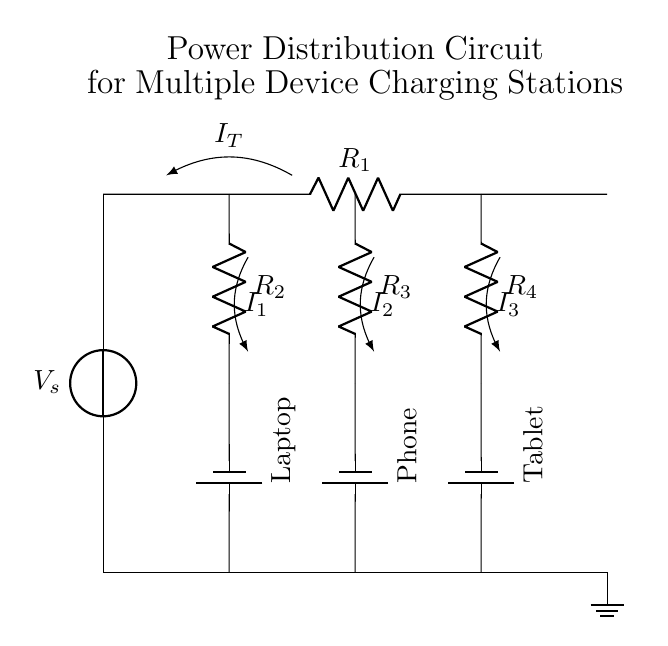What is the voltage source in this circuit? The voltage source is labeled as V_s, indicating the supply voltage for the circuit.
Answer: V_s What are the resistors in this circuit? The circuit contains four resistors labeled R_1, R_2, R_3, and R_4, each connected in different branches for current division.
Answer: R_1, R_2, R_3, R_4 How many charging stations are present in this circuit? There are three charging stations labeled for a Laptop, a Phone, and a Tablet, indicating the specific devices being powered.
Answer: Three What is the total current entering the circuit? The total current entering the circuit is labeled as I_T, which is the combined current flowing from the voltage source before it splits into different branches.
Answer: I_T What is the relationship between branch resistance and current? According to Ohm's Law, the current in each branch is inversely proportional to the branch's resistance; lower resistance allows more current to flow.
Answer: Inversely proportional Which device would receive the most current? The device connected to the branch with the smallest resistance will receive the most current, which can be determined by comparing the resistor values.
Answer: Smallest resistance What happens if one device is disconnected? If one device is disconnected, the total current would redistribute among the remaining devices, affecting the current flow according to their resistances.
Answer: Redistributes current 